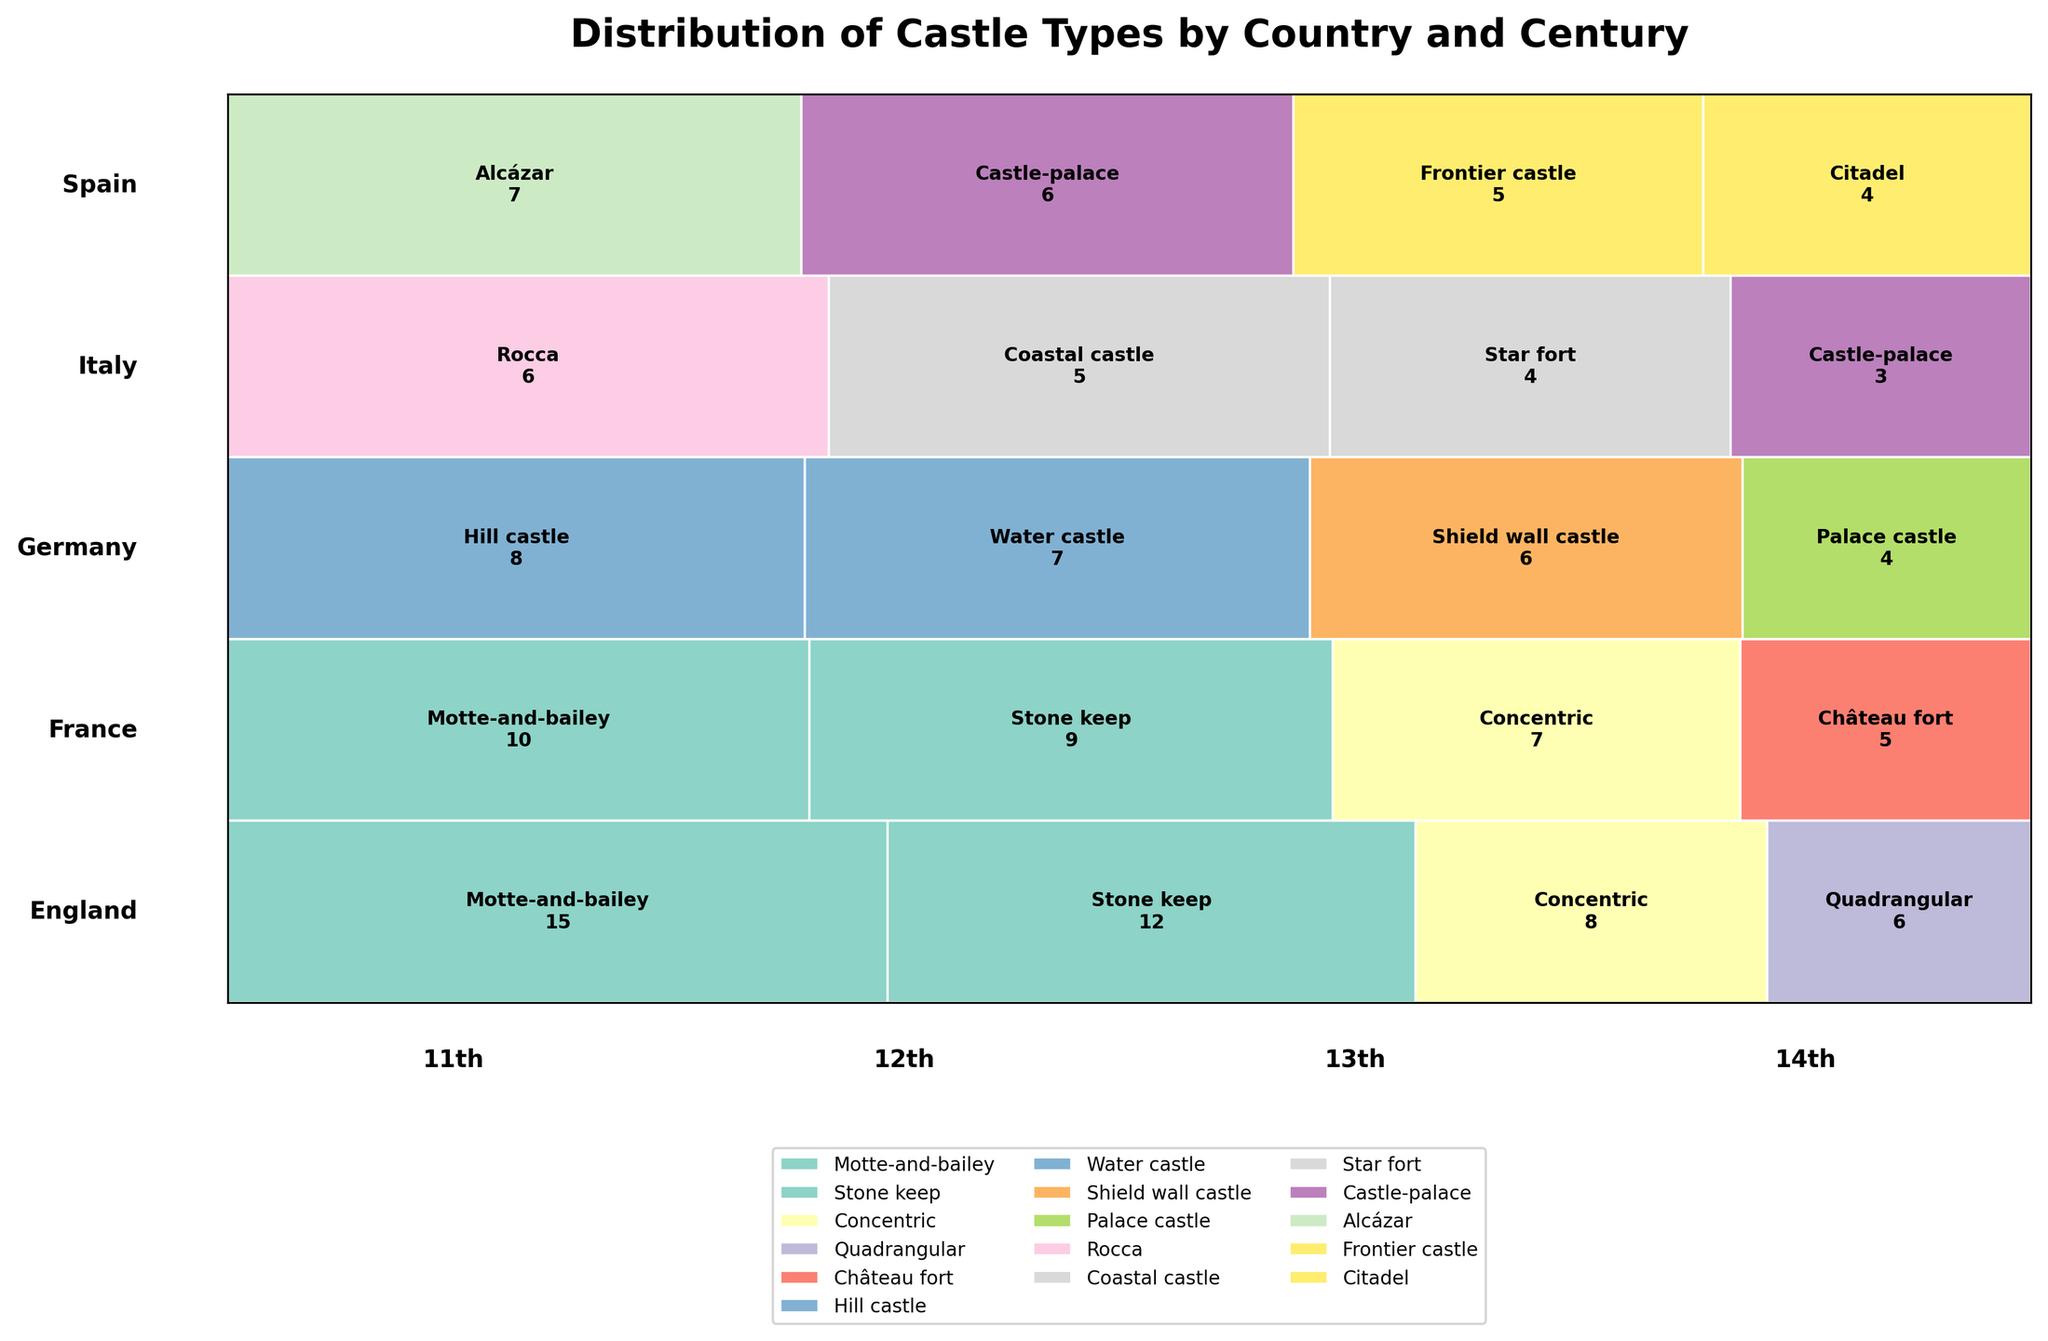What is the most common type of castle built in England in the 12th century? First, we look for the section of the plot corresponding to England in the 12th century. Next, we find the largest block within this section. According to the figure, the largest block is labeled with "Stone keep" and has a count of 12, indicating it's the most common type.
Answer: Stone keep Which country built the most motte-and-bailey castles in the 11th century? To answer this question, we need to compare the sizes of the blocks labeled "Motte-and-bailey" within the 11th-century sections for each country. England's section shows the largest block with a count of 15. Therefore, England built the most motte-and-bailey castles in the 11th century.
Answer: England Out of all the countries, which has the highest total number of castles constructed? We add up the total counts of castles for each country, visible as the cumulative length of the bars per country. The figure shows that England has the longest total bar when counting all centuries, with the sum of all counts being higher than others.
Answer: England How many types of castles were built in Spain during the 14th century? To find the answer, we look at the section for Spain in the 14th century and count all distinct blocks (each representing a different type of castle). The plot shows blocks for "Citadel" only.
Answer: 1 Which century saw the highest variety of castle types being constructed in France? We check the blocks for France in each century and count the unique types within each time frame. The 11th century has "Motte-and-bailey," the 12th has "Stone keep," the 13th has "Concentric," and the 14th century has the highest variety with the unique "Château fort" type.
Answer: 14th In the 13th century, which two countries built exactly one type of castle each? For the 13th-century sections, we identify sections with only one distinct block. Germany has only "Shield wall castle" and Italy has only "Star fort", both having single unique types.
Answer: Germany and Italy What is the least common castle type in the 11th century among all depicted countries? We look at the counts for each castle type in the 11th century sections and find the lowest value. "Rocca" in Italy shows the lowest count with a number of 6.
Answer: Rocca Which country saw a decline in the number of castles built from the 11th to the 14th century? We need to sum the counts for each century for each country and observe the trend. Italy's total numbers decline from 6 (11th century), 5 (12th century), 4 (13th century), to 3 (14th century).
Answer: Italy Between castle types Concentric and Château fort constructed in France, which had more total castles built over all centuries? We sum up the counts for "Concentric" and "Château fort" in France across all centuries. "Concentric" has counts of 7 in the 13th century, "Château fort" has 5 in the 14th century, so "Concentric" has more.
Answer: Concentric 